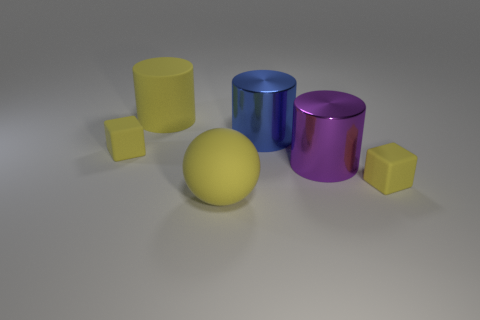What shape is the yellow rubber thing that is on the right side of the yellow matte cylinder and behind the rubber ball? cube 